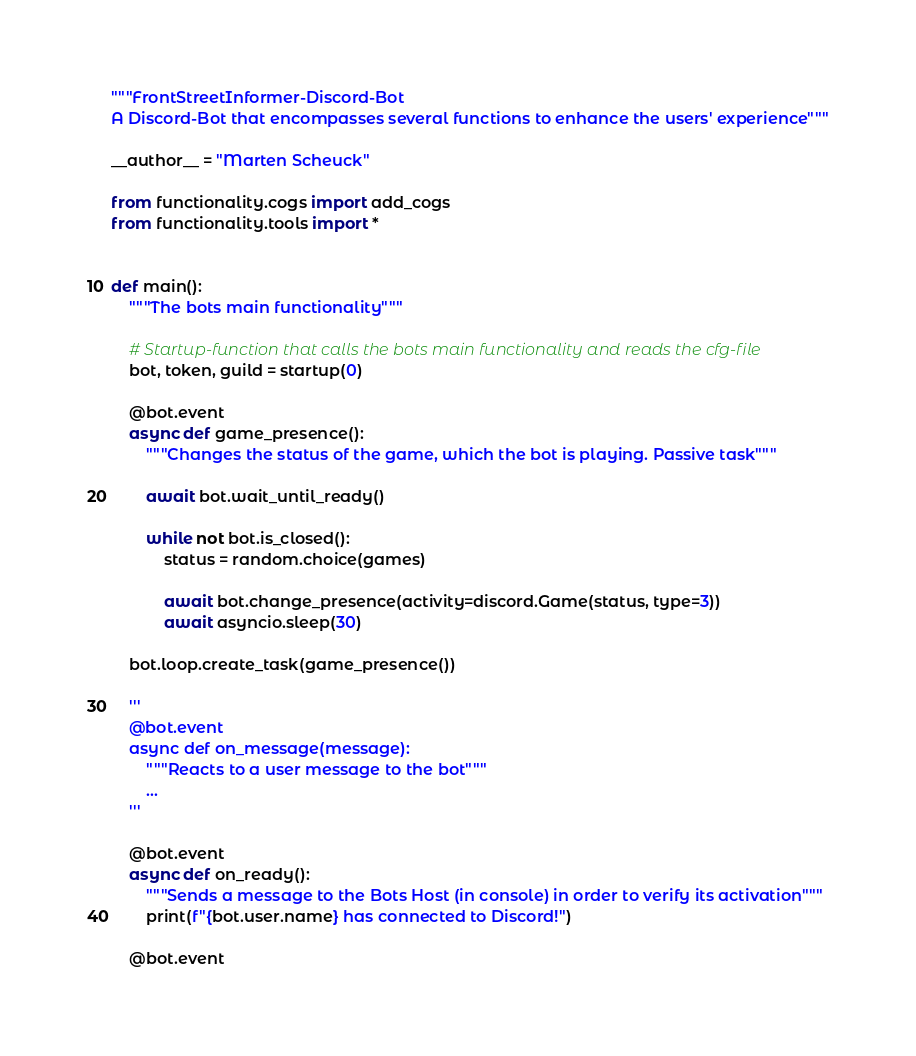Convert code to text. <code><loc_0><loc_0><loc_500><loc_500><_Python_>"""FrontStreetInformer-Discord-Bot
A Discord-Bot that encompasses several functions to enhance the users' experience"""

__author__ = "Marten Scheuck"

from functionality.cogs import add_cogs
from functionality.tools import *


def main():
    """The bots main functionality"""

    # Startup-function that calls the bots main functionality and reads the cfg-file
    bot, token, guild = startup(0)

    @bot.event
    async def game_presence():
        """Changes the status of the game, which the bot is playing. Passive task"""

        await bot.wait_until_ready()

        while not bot.is_closed():
            status = random.choice(games)

            await bot.change_presence(activity=discord.Game(status, type=3))
            await asyncio.sleep(30)

    bot.loop.create_task(game_presence())

    '''
    @bot.event
    async def on_message(message):
        """Reacts to a user message to the bot"""
        ...
    '''

    @bot.event
    async def on_ready():
        """Sends a message to the Bots Host (in console) in order to verify its activation"""
        print(f"{bot.user.name} has connected to Discord!")

    @bot.event</code> 